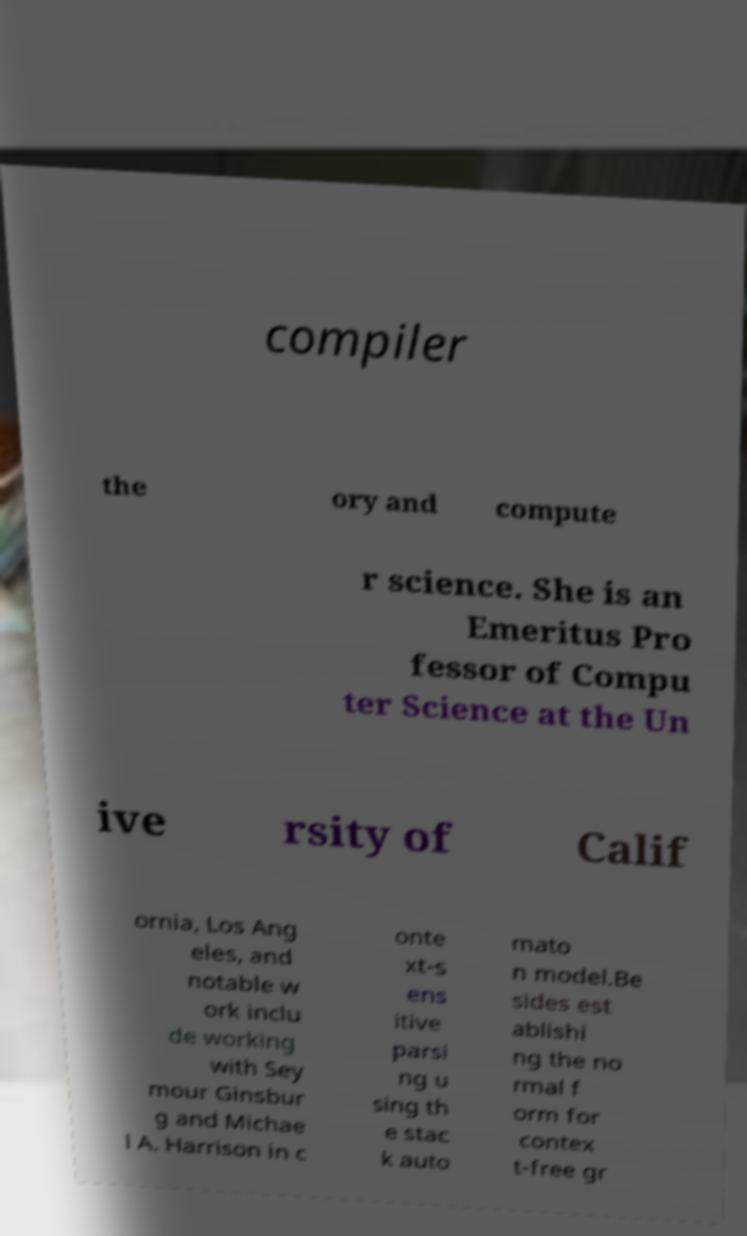What messages or text are displayed in this image? I need them in a readable, typed format. compiler the ory and compute r science. She is an Emeritus Pro fessor of Compu ter Science at the Un ive rsity of Calif ornia, Los Ang eles, and notable w ork inclu de working with Sey mour Ginsbur g and Michae l A. Harrison in c onte xt-s ens itive parsi ng u sing th e stac k auto mato n model.Be sides est ablishi ng the no rmal f orm for contex t-free gr 